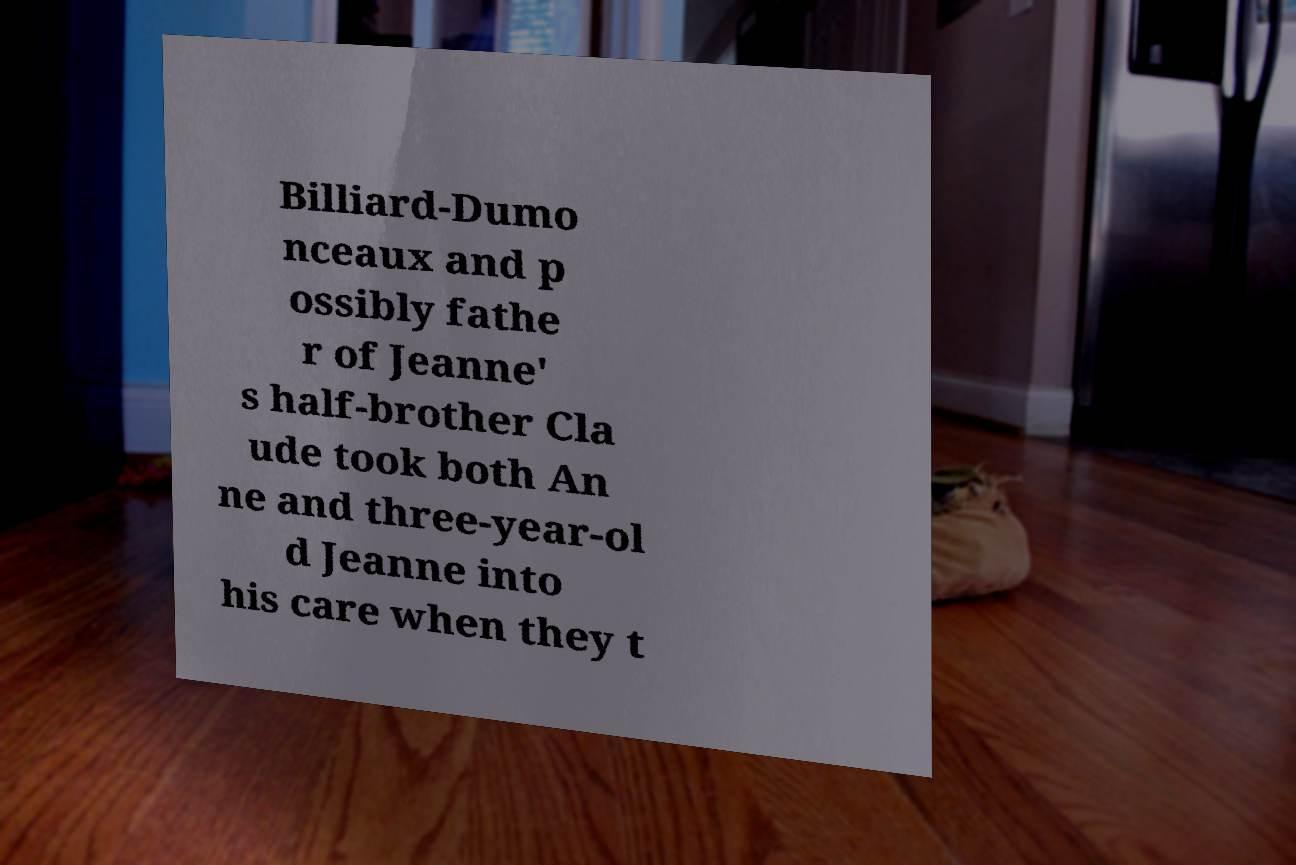What messages or text are displayed in this image? I need them in a readable, typed format. Billiard-Dumo nceaux and p ossibly fathe r of Jeanne' s half-brother Cla ude took both An ne and three-year-ol d Jeanne into his care when they t 